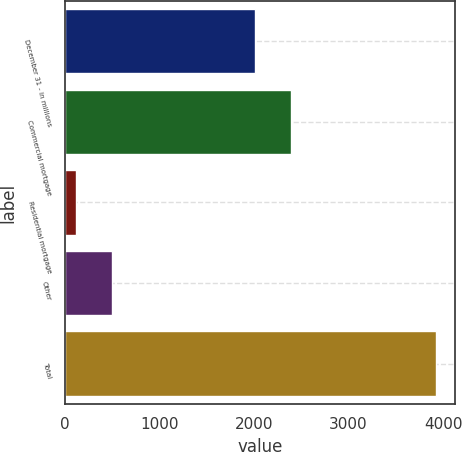Convert chart to OTSL. <chart><loc_0><loc_0><loc_500><loc_500><bar_chart><fcel>December 31 - in millions<fcel>Commercial mortgage<fcel>Residential mortgage<fcel>Other<fcel>Total<nl><fcel>2007<fcel>2388<fcel>117<fcel>498<fcel>3927<nl></chart> 